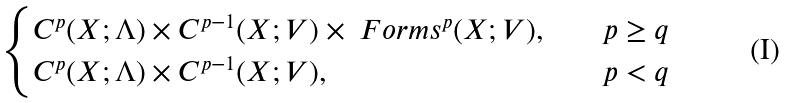<formula> <loc_0><loc_0><loc_500><loc_500>\begin{cases} C ^ { p } ( X ; \Lambda ) \times C ^ { p - 1 } ( X ; V ) \times \ F o r m s ^ { p } ( X ; V ) , & \quad p \geq { q } \\ C ^ { p } ( X ; \Lambda ) \times C ^ { p - 1 } ( X ; V ) , & \quad p < { q } \end{cases}</formula> 